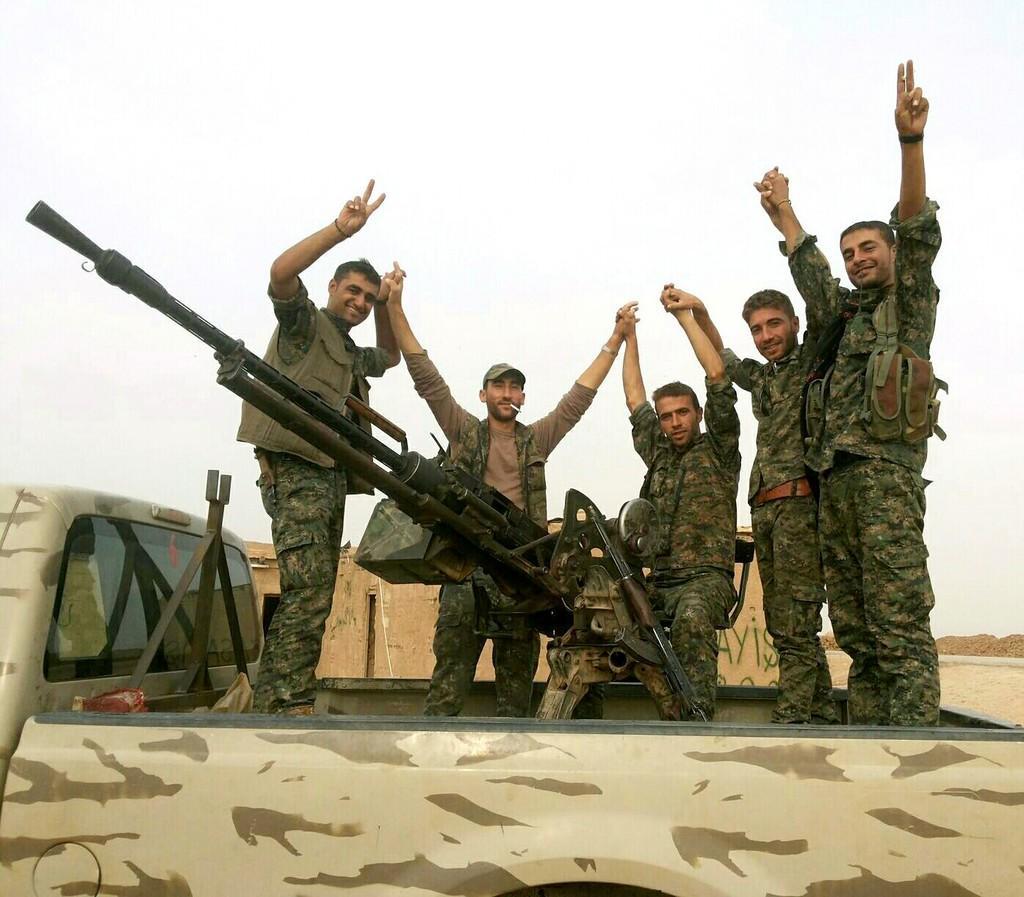Could you give a brief overview of what you see in this image? In this image we can see people standing in the vehicle. They are all wearing uniforms and we can see a rifle placed on the stand. In the background there is sky. 